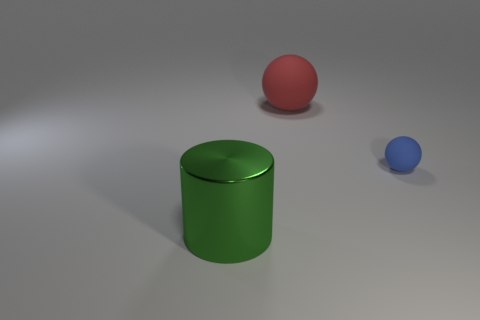Are there any other things that are the same material as the cylinder?
Give a very brief answer. No. Is there anything else that has the same size as the blue matte sphere?
Keep it short and to the point. No. There is a object that is in front of the large red matte object and to the right of the green object; what size is it?
Your response must be concise. Small. Does the red matte ball have the same size as the metal cylinder?
Provide a short and direct response. Yes. There is a large ball; what number of small things are in front of it?
Your answer should be compact. 1. Is the number of large metallic cylinders greater than the number of small matte cylinders?
Offer a very short reply. Yes. What shape is the object that is right of the green cylinder and to the left of the blue rubber ball?
Give a very brief answer. Sphere. Are any red objects visible?
Keep it short and to the point. Yes. What is the shape of the big thing left of the big thing that is on the right side of the big object that is on the left side of the large matte ball?
Offer a very short reply. Cylinder. What number of other small rubber things have the same shape as the blue thing?
Make the answer very short. 0. 